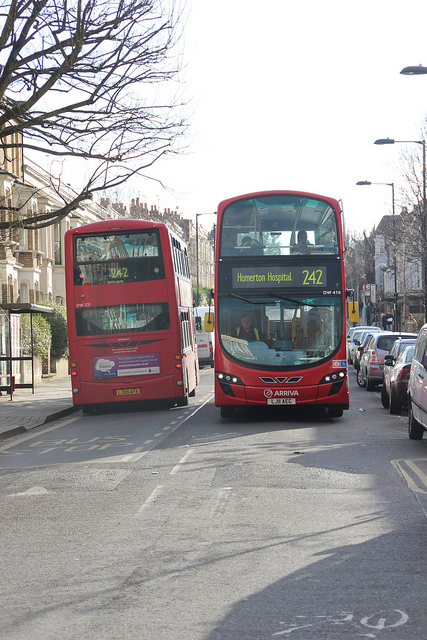Please identify all text content in this image. Homerton Hospital 242 ARRIVA 242 BUS 